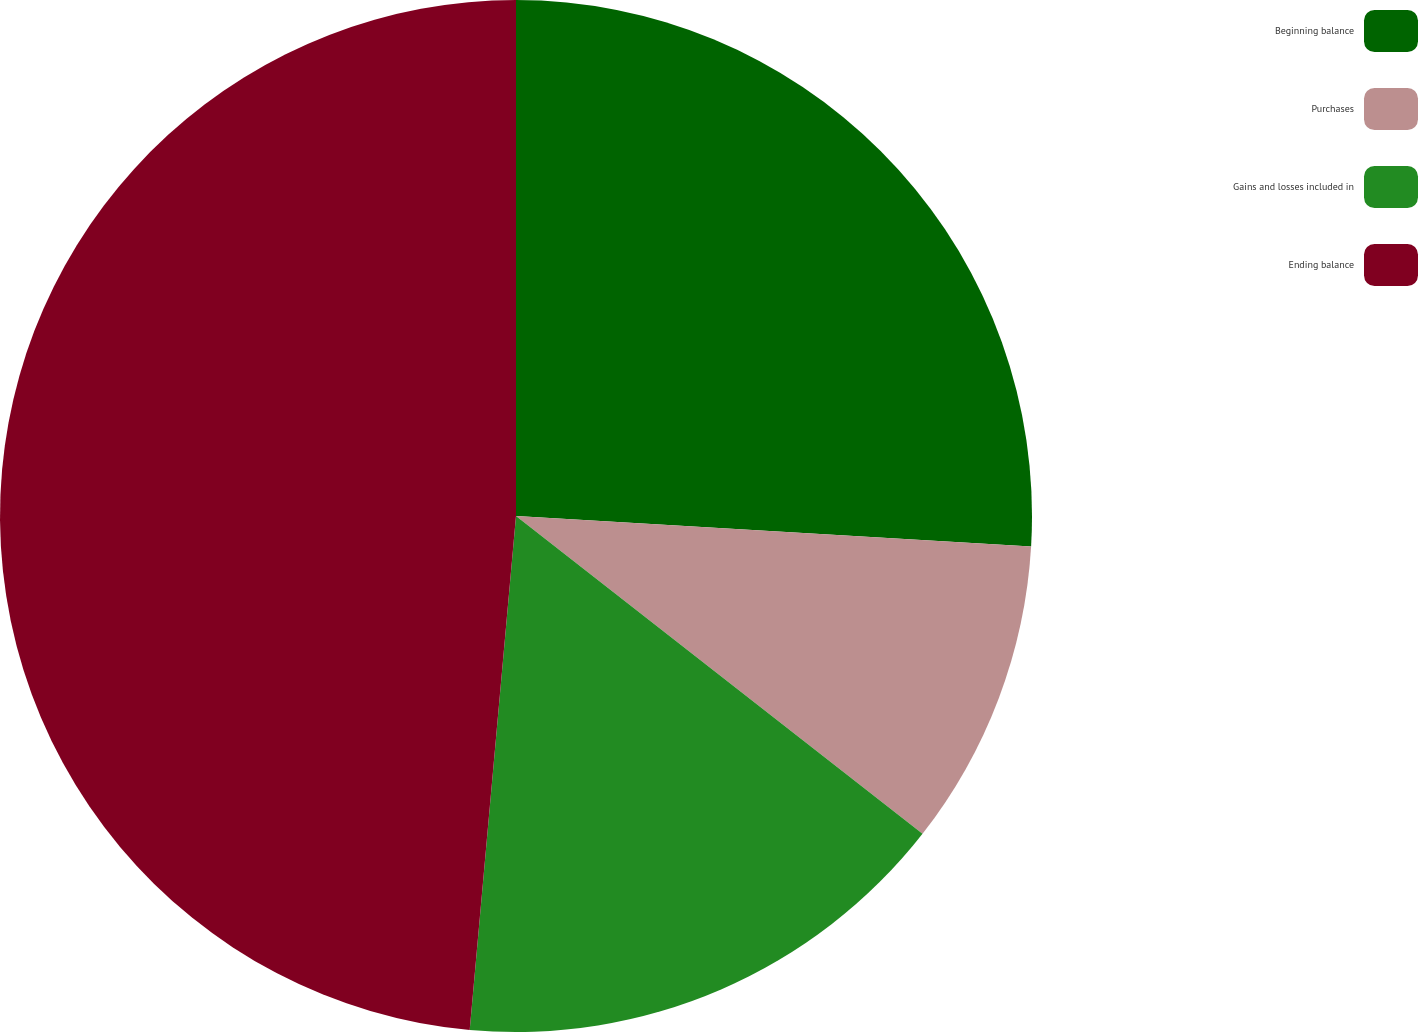<chart> <loc_0><loc_0><loc_500><loc_500><pie_chart><fcel>Beginning balance<fcel>Purchases<fcel>Gains and losses included in<fcel>Ending balance<nl><fcel>25.94%<fcel>9.62%<fcel>15.87%<fcel>48.57%<nl></chart> 